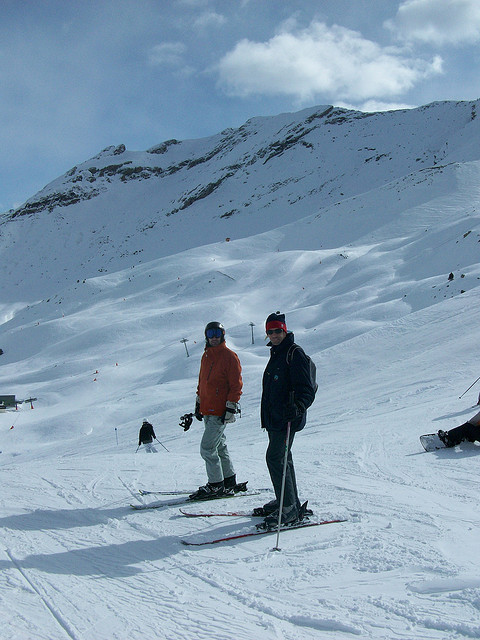<image>How many people are skateboarding in this picture? I am not sure. It might be none since they are snowboarding. How many people are skateboarding in this picture? There are no people skateboarding in this picture. They are snowboarding instead. 